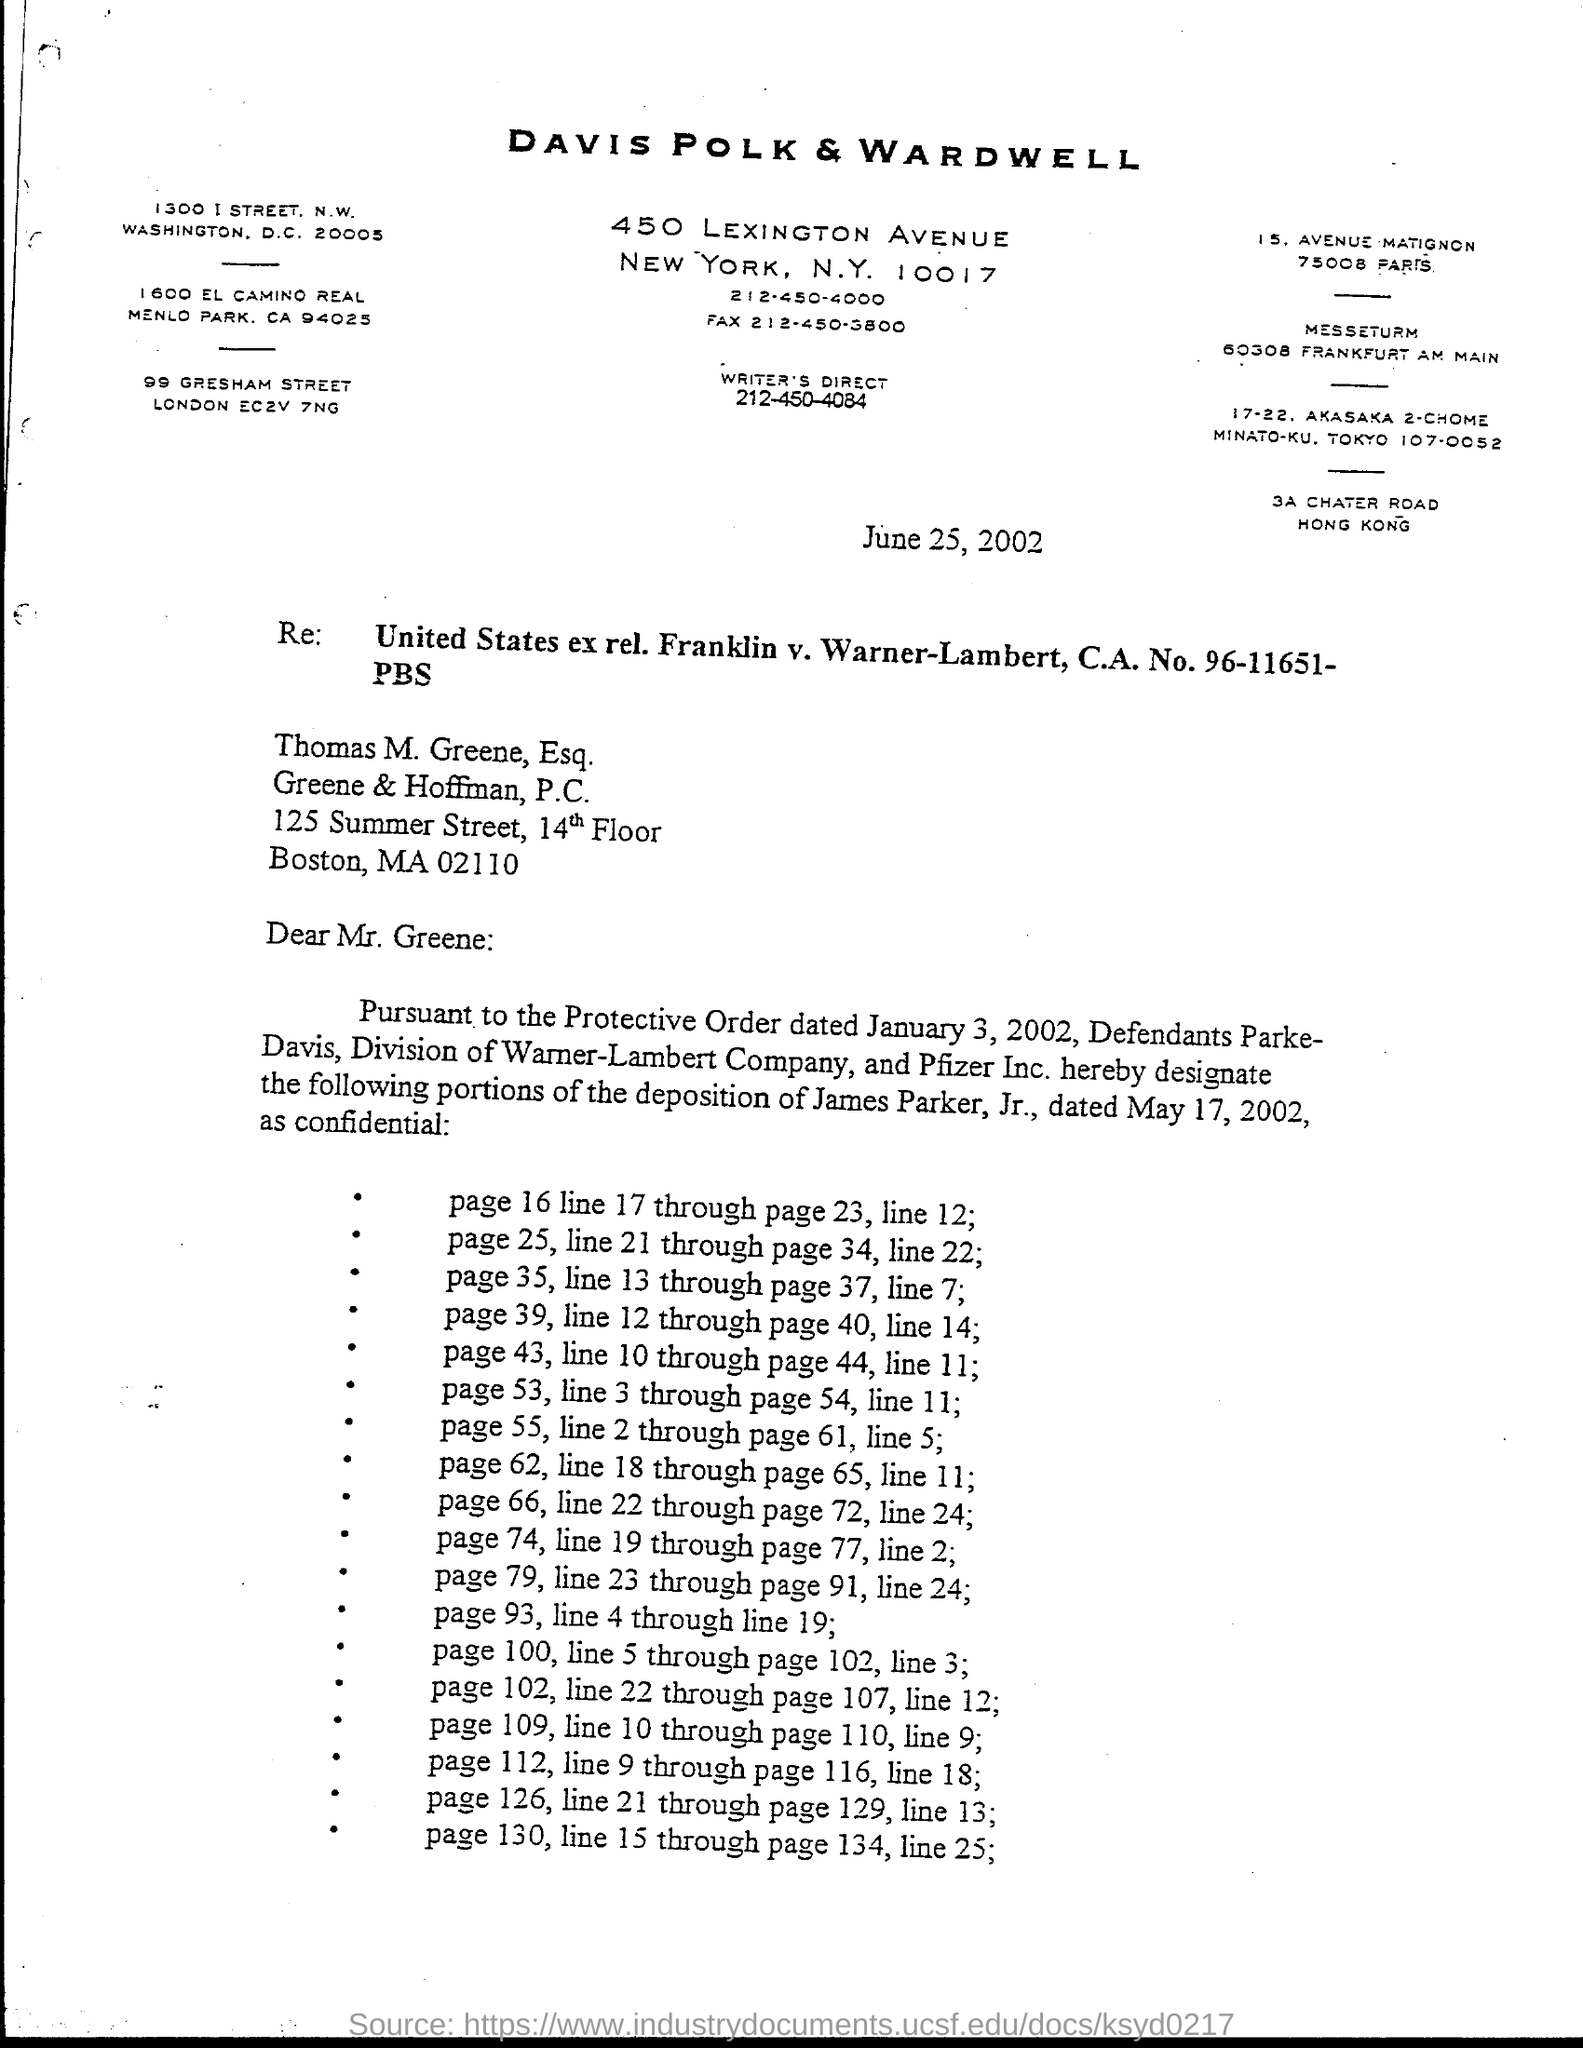Outline some significant characteristics in this image. The issued date of this letter is June 25, 2002. The letter bears the title of the company Davis Polk & Wardwell, which is mentioned in the letter head. 